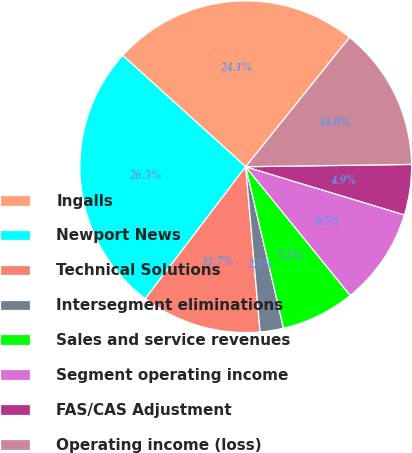Convert chart to OTSL. <chart><loc_0><loc_0><loc_500><loc_500><pie_chart><fcel>Ingalls<fcel>Newport News<fcel>Technical Solutions<fcel>Intersegment eliminations<fcel>Sales and service revenues<fcel>Segment operating income<fcel>FAS/CAS Adjustment<fcel>Operating income (loss)<nl><fcel>24.07%<fcel>26.35%<fcel>11.74%<fcel>2.28%<fcel>7.19%<fcel>9.46%<fcel>4.91%<fcel>14.01%<nl></chart> 